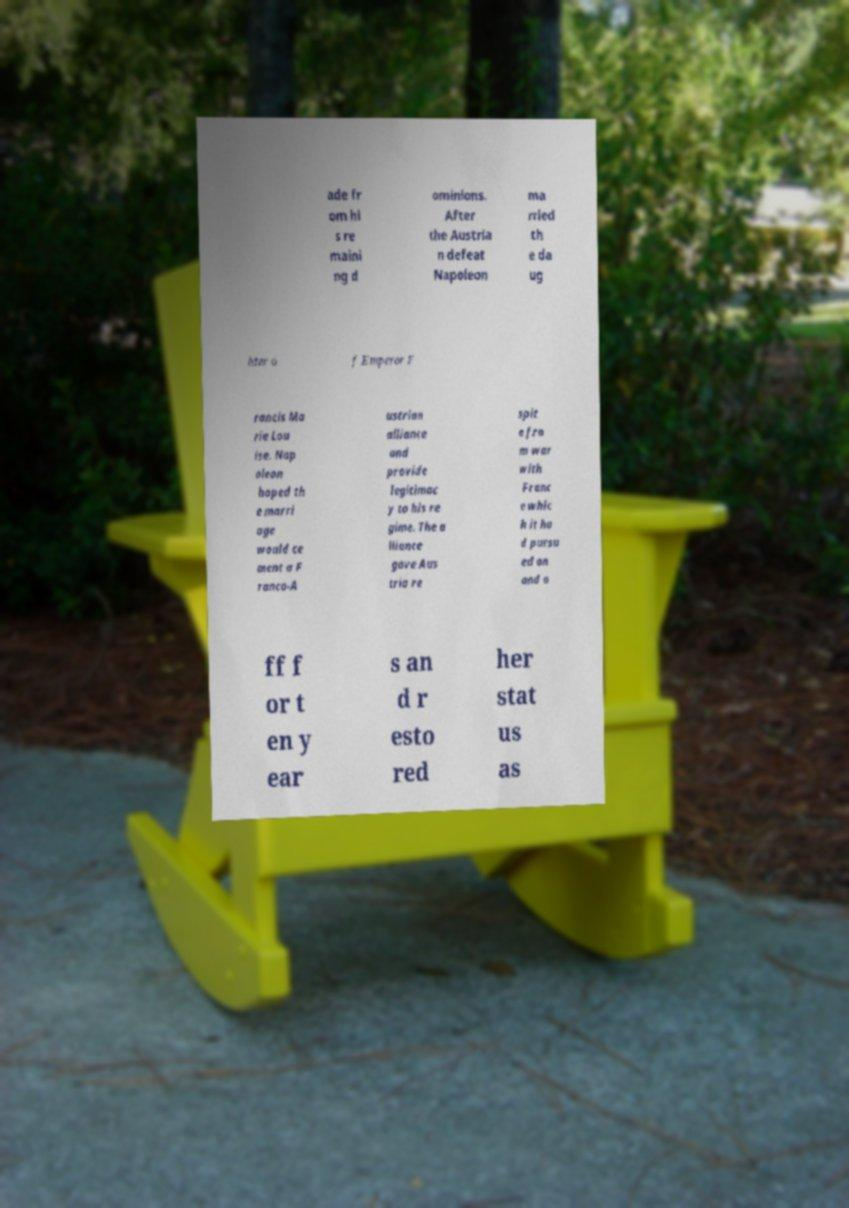Please identify and transcribe the text found in this image. ade fr om hi s re maini ng d ominions. After the Austria n defeat Napoleon ma rried th e da ug hter o f Emperor F rancis Ma rie Lou ise. Nap oleon hoped th e marri age would ce ment a F ranco-A ustrian alliance and provide legitimac y to his re gime. The a lliance gave Aus tria re spit e fro m war with Franc e whic h it ha d pursu ed on and o ff f or t en y ear s an d r esto red her stat us as 